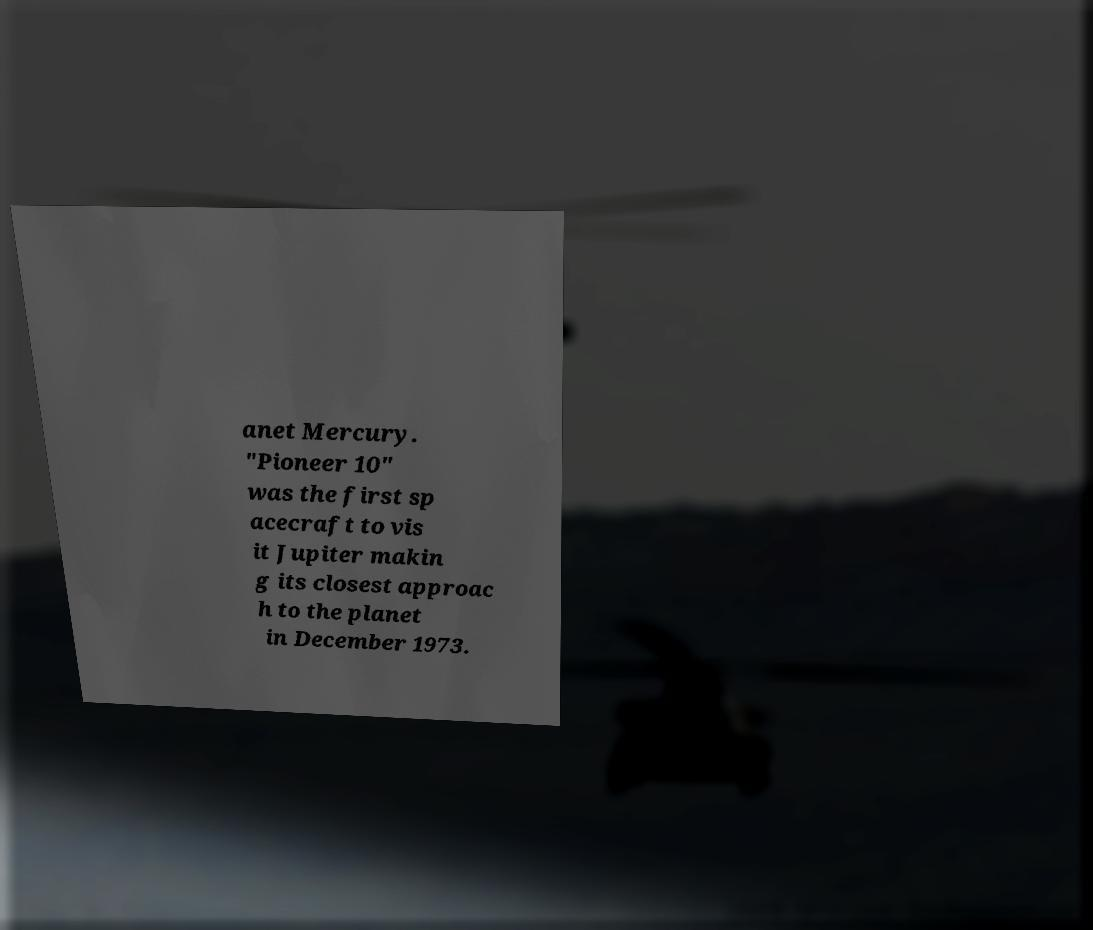Can you read and provide the text displayed in the image?This photo seems to have some interesting text. Can you extract and type it out for me? anet Mercury. "Pioneer 10" was the first sp acecraft to vis it Jupiter makin g its closest approac h to the planet in December 1973. 